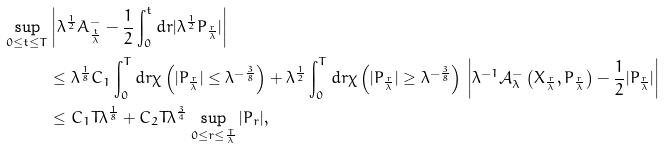<formula> <loc_0><loc_0><loc_500><loc_500>\sup _ { 0 \leq t \leq T } & \left | \lambda ^ { \frac { 1 } { 2 } } A _ { \frac { t } { \lambda } } ^ { - } - \frac { 1 } { 2 } \int _ { 0 } ^ { t } d r | \lambda ^ { \frac { 1 } { 2 } } P _ { \frac { r } { \lambda } } | \right | \\ & \leq \lambda ^ { \frac { 1 } { 8 } } C _ { 1 } \int _ { 0 } ^ { T } d r \chi \left ( | P _ { \frac { r } { \lambda } } | \leq \lambda ^ { - \frac { 3 } { 8 } } \right ) + \lambda ^ { \frac { 1 } { 2 } } \int _ { 0 } ^ { T } d r \chi \left ( | P _ { \frac { r } { \lambda } } | \geq \lambda ^ { - \frac { 3 } { 8 } } \right ) \, \left | \lambda ^ { - 1 } \mathcal { A } _ { \lambda } ^ { - } \left ( X _ { \frac { r } { \lambda } } , P _ { \frac { r } { \lambda } } \right ) - \frac { 1 } { 2 } | P _ { \frac { r } { \lambda } } | \right | \\ & \leq C _ { 1 } T \lambda ^ { \frac { 1 } { 8 } } + C _ { 2 } T \lambda ^ { \frac { 3 } { 4 } } \sup _ { 0 \leq r \leq \frac { T } { \lambda } } | P _ { r } | ,</formula> 